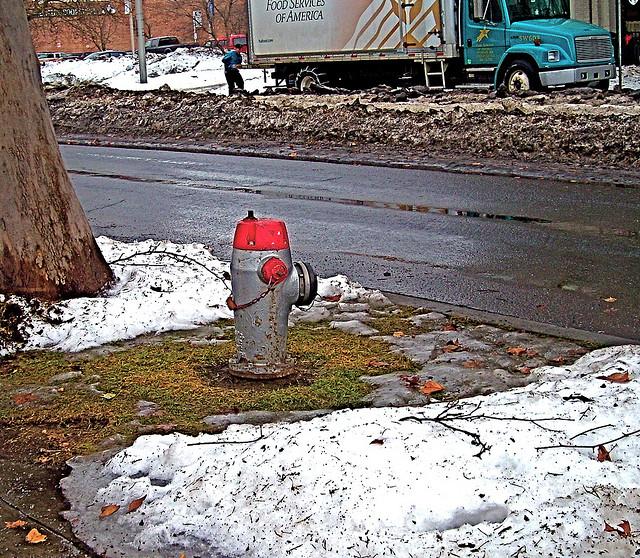What is the gray and red thing used for?
Short answer required. Fire hydrant. Where is the truck parked?
Be succinct. Across street. Is there any snow present in this picture?
Answer briefly. Yes. Is the ground dry?
Quick response, please. No. 